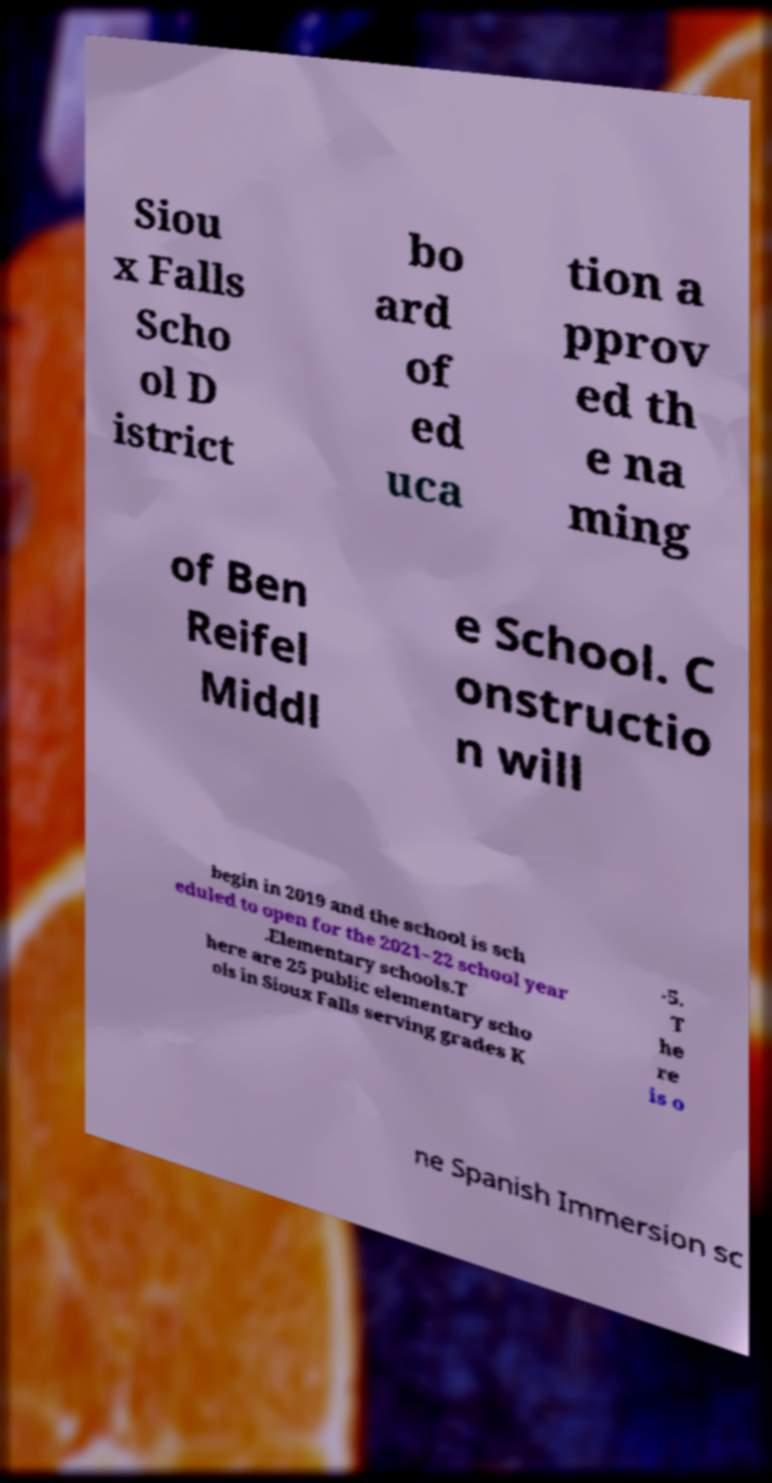Can you read and provide the text displayed in the image?This photo seems to have some interesting text. Can you extract and type it out for me? Siou x Falls Scho ol D istrict bo ard of ed uca tion a pprov ed th e na ming of Ben Reifel Middl e School. C onstructio n will begin in 2019 and the school is sch eduled to open for the 2021–22 school year .Elementary schools.T here are 25 public elementary scho ols in Sioux Falls serving grades K -5. T he re is o ne Spanish Immersion sc 